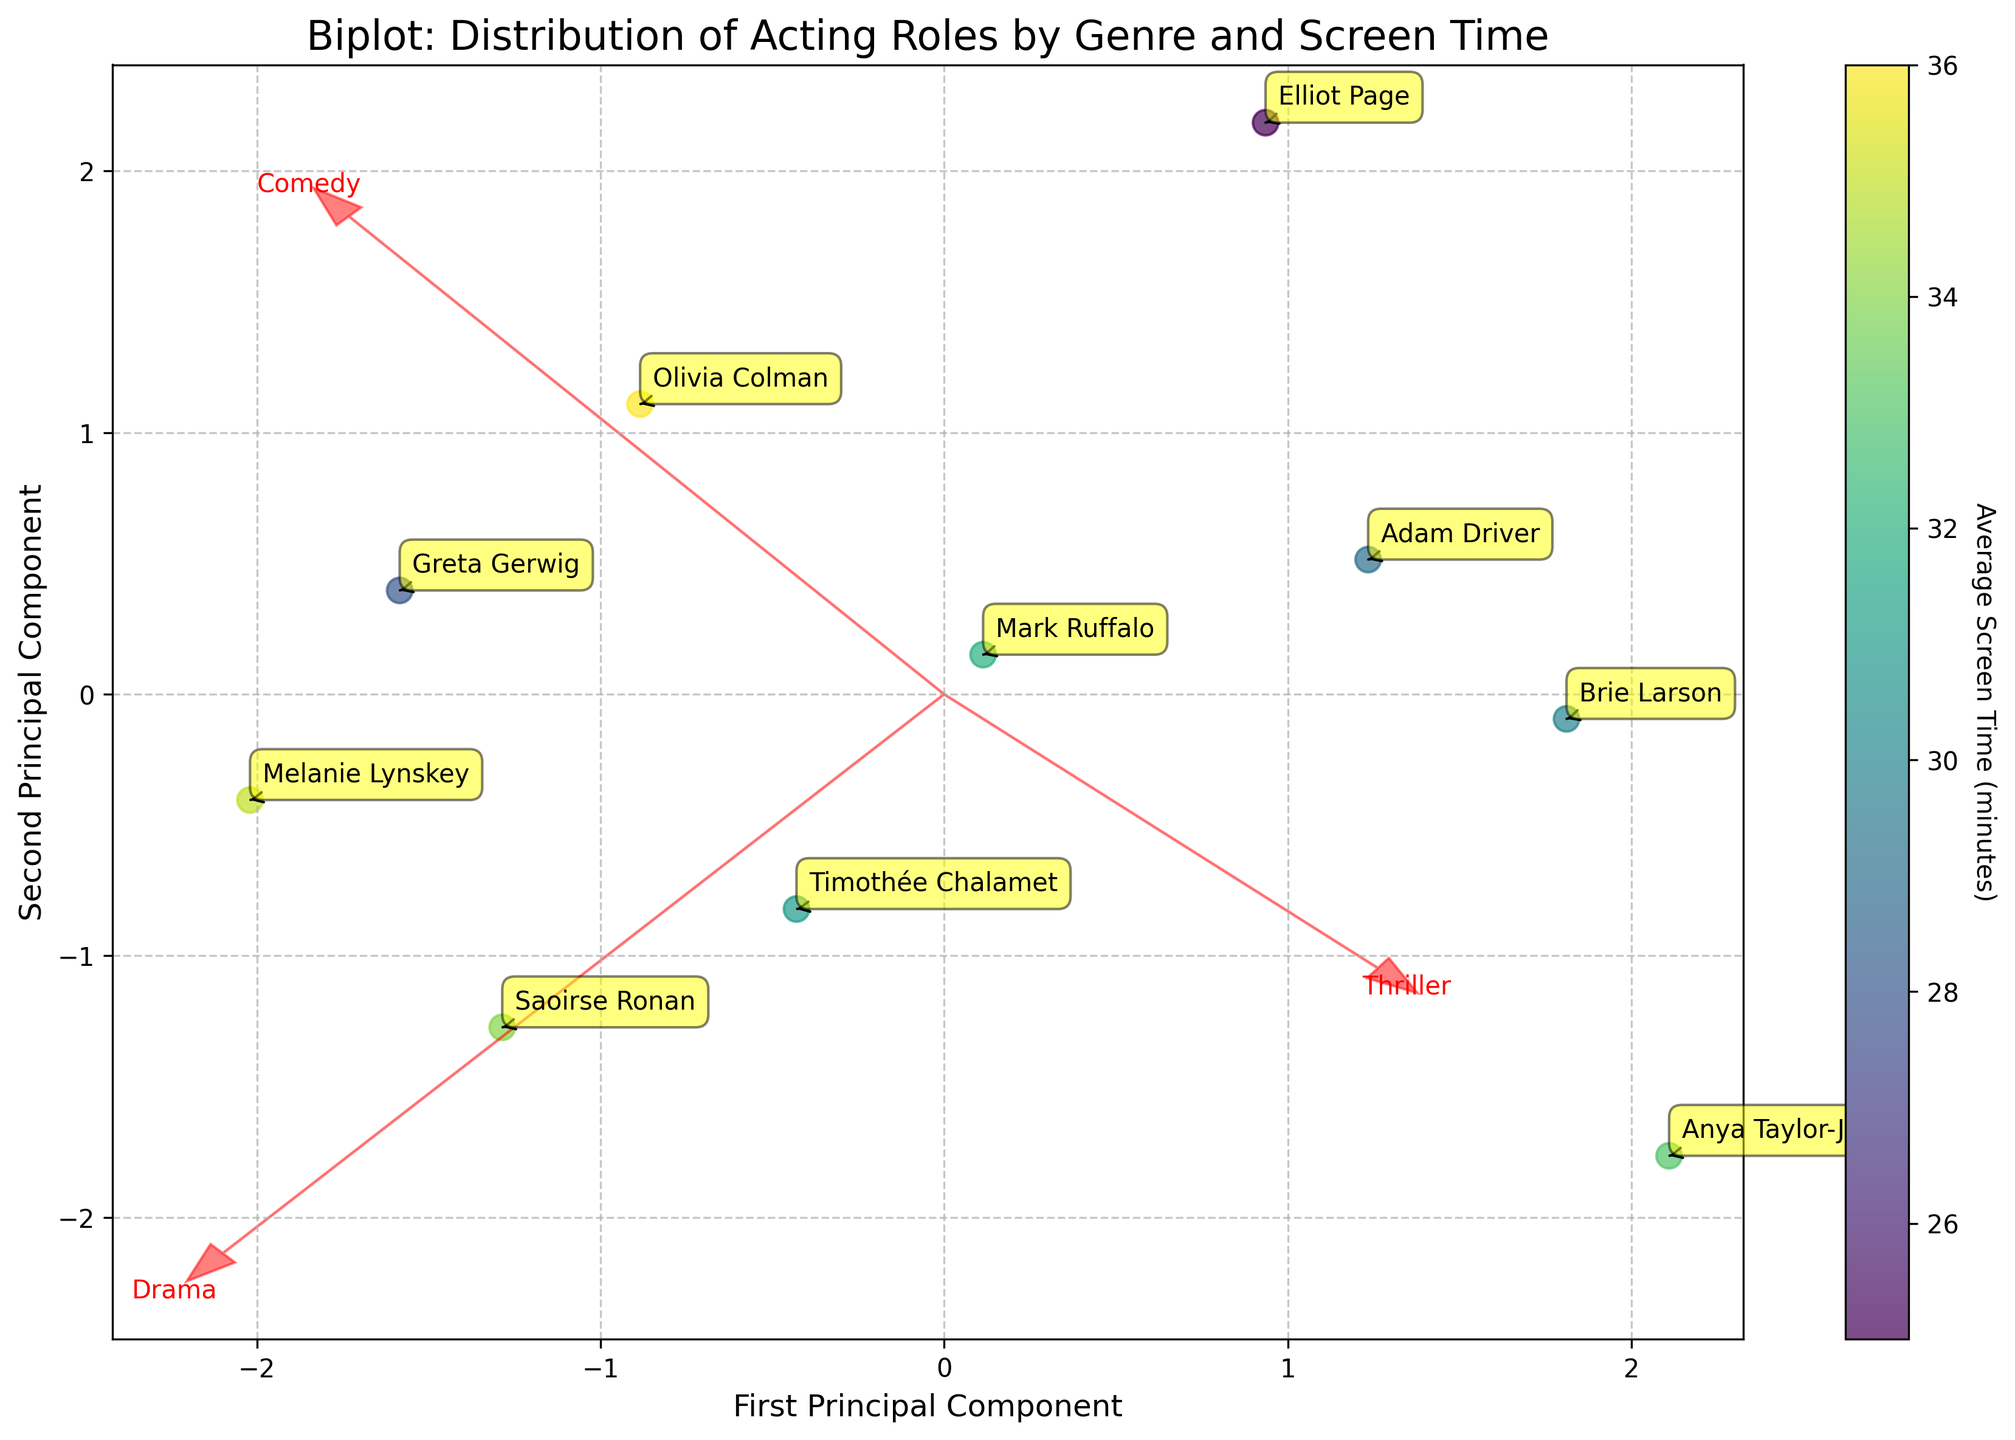What is the title of the biplot? The title is usually located at the top of the plot and gives an overview of what the plot is showing. In this case, the title of the biplot is "Biplot: Distribution of Acting Roles by Genre and Screen Time".
Answer: Biplot: Distribution of Acting Roles by Genre and Screen Time Which genre is most positively correlated with the first principal component? The first principal component is represented on the x-axis. The genre vector most aligned with this axis is the one most positively correlated. From the plot, the 'Drama' vector points most directly towards the positive x-axis.
Answer: Drama Which actor has the highest average screen time, and where is this actor located on the plot? The color gradient of the points indicates average screen time. The actor with the highest average screen time will have the darkest point on the plot. Olivia Colman, with an average screen time of 36, is located in the upper right quadrant of the plot.
Answer: Olivia Colman is in the upper right quadrant What is the average screen time of Melanie Lynskey? The average screen time is indicated by the color of each actor's point. Referring to the plot and data, Melanie Lynskey has an average screen time of 35 minutes.
Answer: 35 minutes Which actor's role distribution is closest to the ‘Thriller’ genre vector? The closest actor's point to the ‘Thriller’ vector indicates they have a higher distribution towards ‘Thriller’ roles. Anya Taylor-Joy, whose point is closest to this vector, suggests her roles are more inclined towards ‘Thriller’.
Answer: Anya Taylor-Joy How are the axes of the biplot labeled? The axes labels provide the names of the components being represented. On the biplot, the x-axis is labeled ‘First Principal Component’ and the y-axis is labeled ‘Second Principal Component’.
Answer: First Principal Component (x-axis), Second Principal Component (y-axis) Who appears to balance their roles across Drama, Comedy, and Thriller most evenly, based on their position relative to the origin? Actors closest to the origin likely have a more balanced role distribution across the three genres. Elliot Page, whose point is nearest to the origin, shows a balanced distribution between Drama, Comedy, and Thriller.
Answer: Elliot Page Identify two actors that have a similar role distribution pattern but differ significantly in average screen time. To find two such actors, we look for points close to each other with notably different colors. Melanie Lynskey and Olivia Colman are close in role distribution but differ in screen time, as indicated by their differing point colors (Melanie Lynskey with 35 minutes, Olivia Colman with 36 minutes).
Answer: Melanie Lynskey and Olivia Colman What does the color bar signify? The color bar typically represents a gradient to indicate a numeric value. In this plot, it shows the average screen time for each actor, with different colors corresponding to different screen times.
Answer: Average screen time 